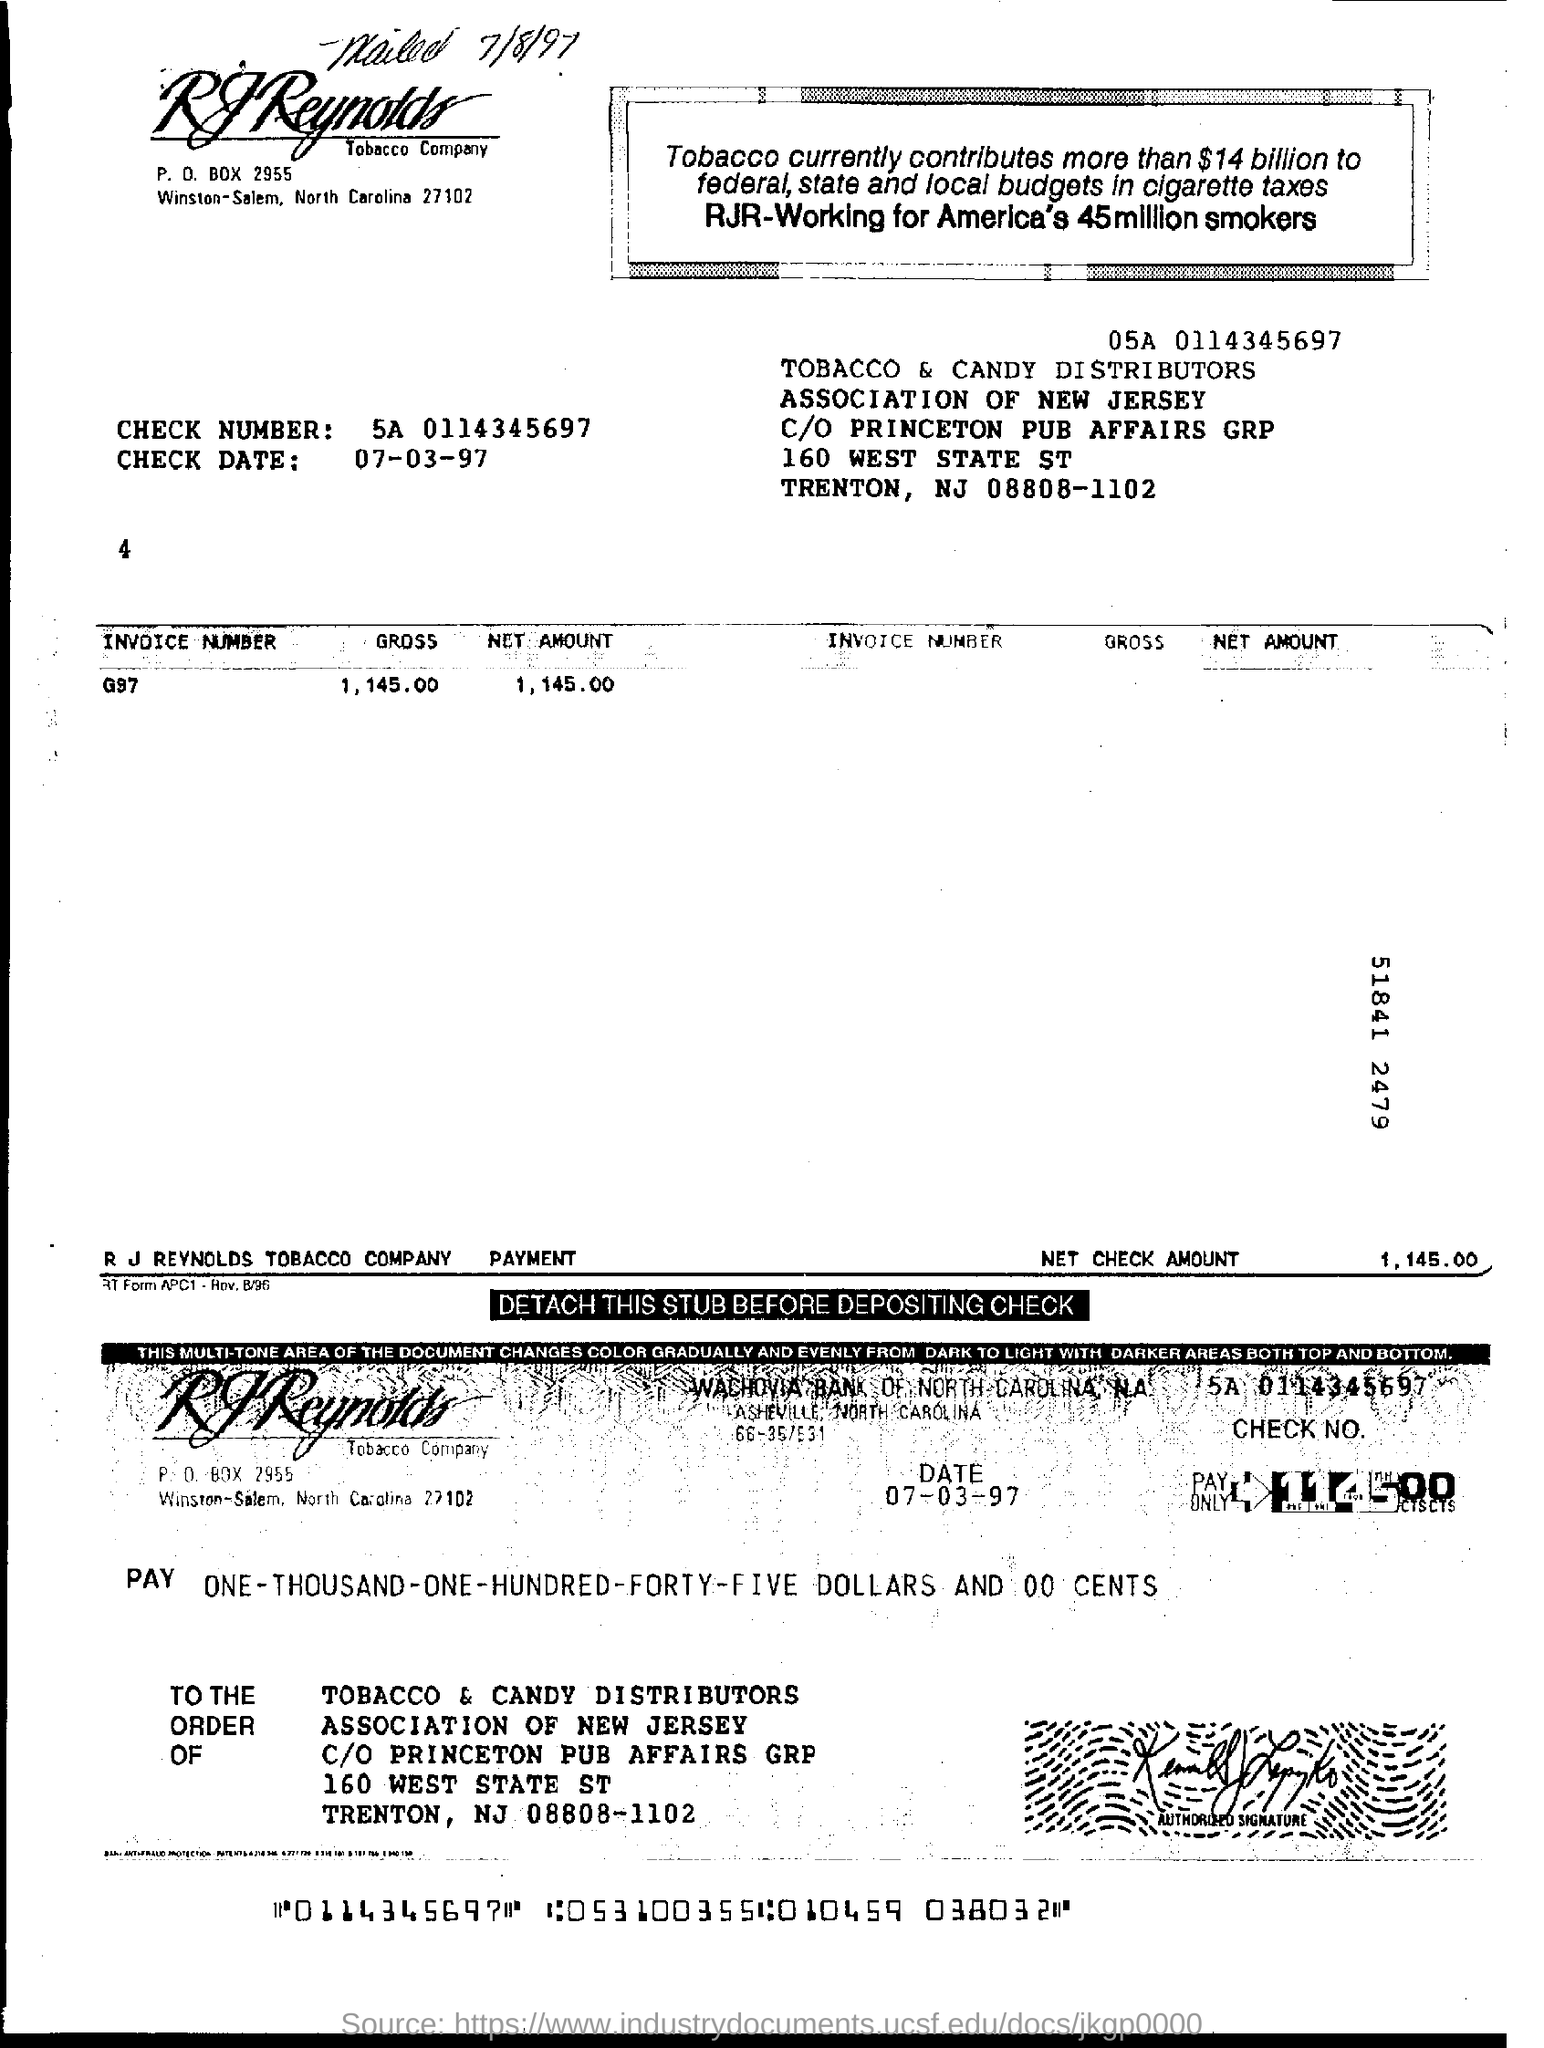What is the invoice number given in the document?
Keep it short and to the point. G97. What is the net check amount mentioned in the invoice?
Your answer should be compact. 1, 145.00. What is the check no given in the invoice?
Your response must be concise. 5A 0114345697. What is the check date mentioned in the invoice?
Your answer should be very brief. 07-03-97. 